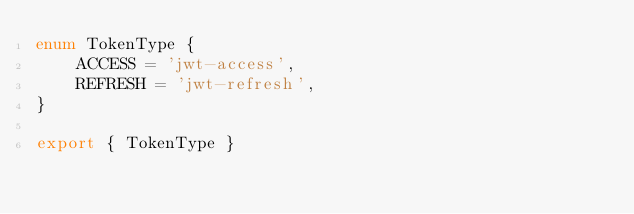Convert code to text. <code><loc_0><loc_0><loc_500><loc_500><_TypeScript_>enum TokenType {
    ACCESS = 'jwt-access',
    REFRESH = 'jwt-refresh',
}

export { TokenType }
</code> 